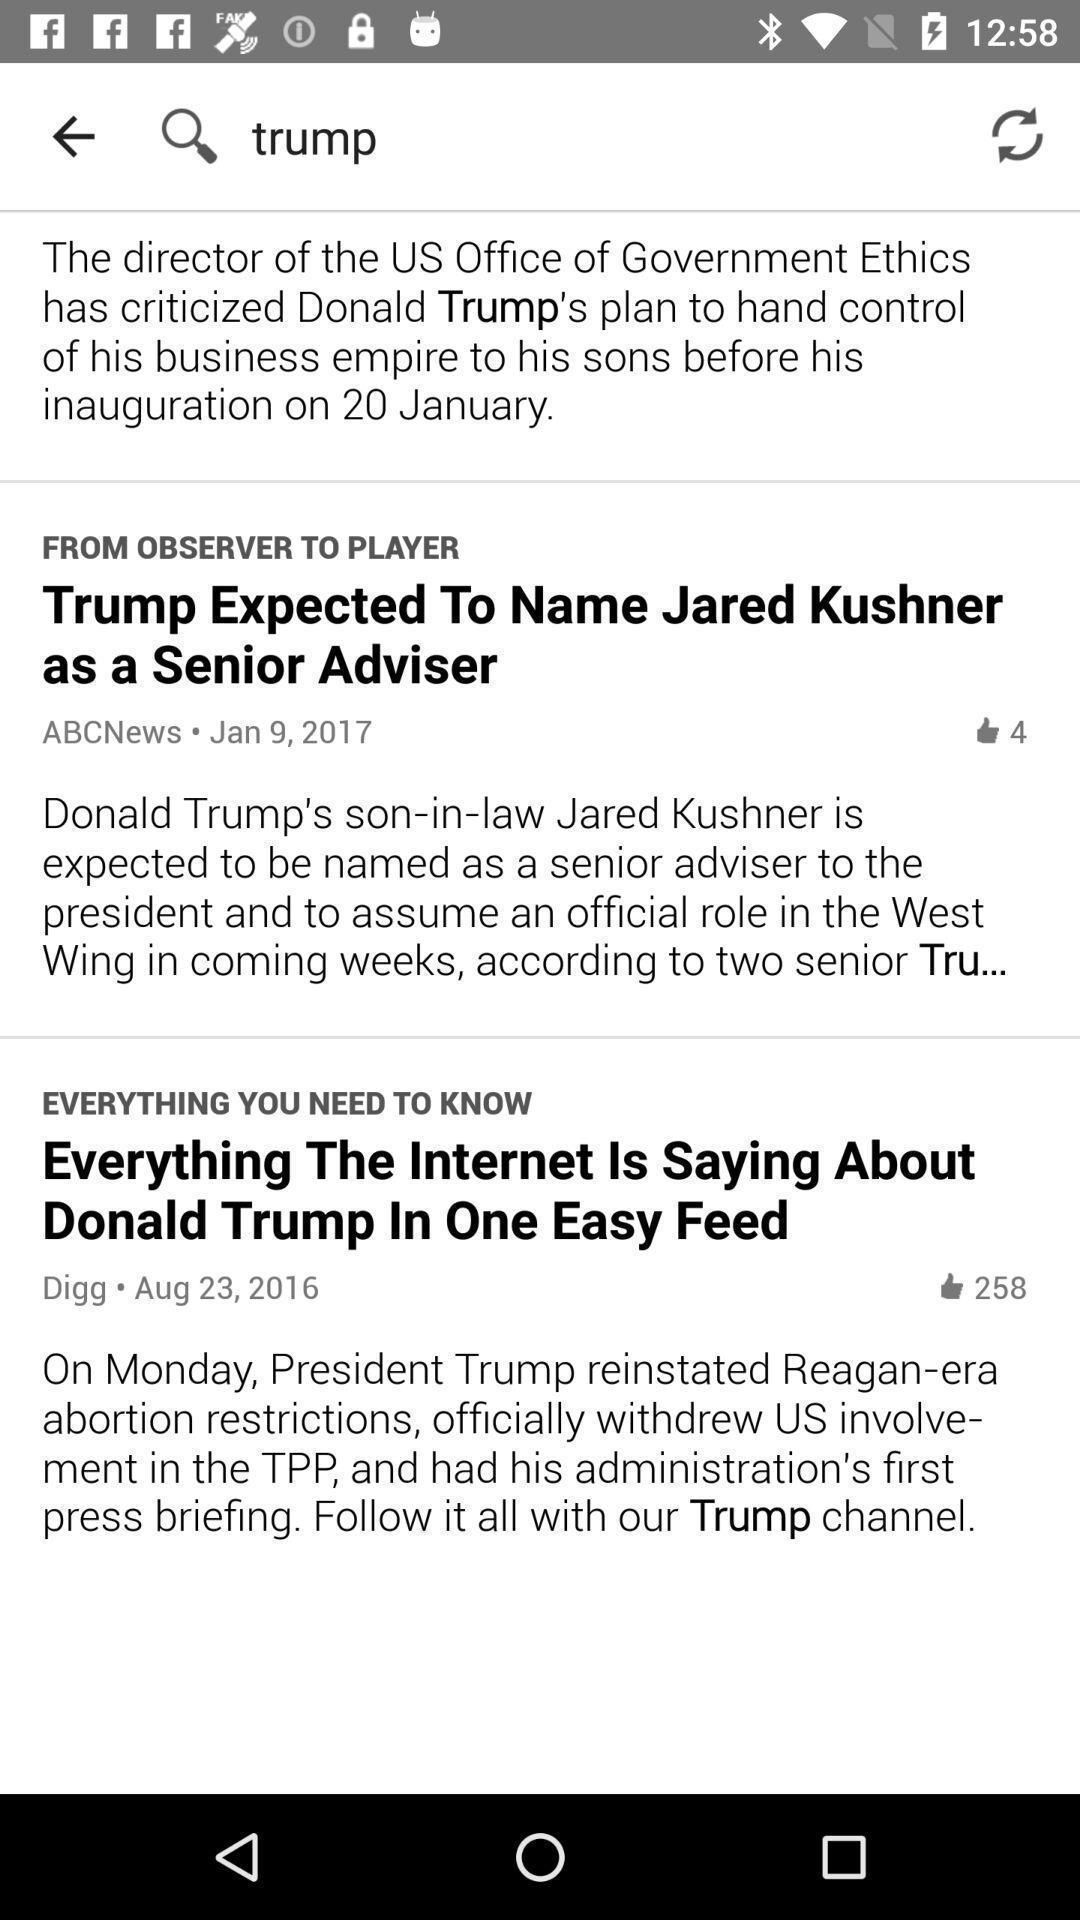Tell me what you see in this picture. Screen showing different type of news. 